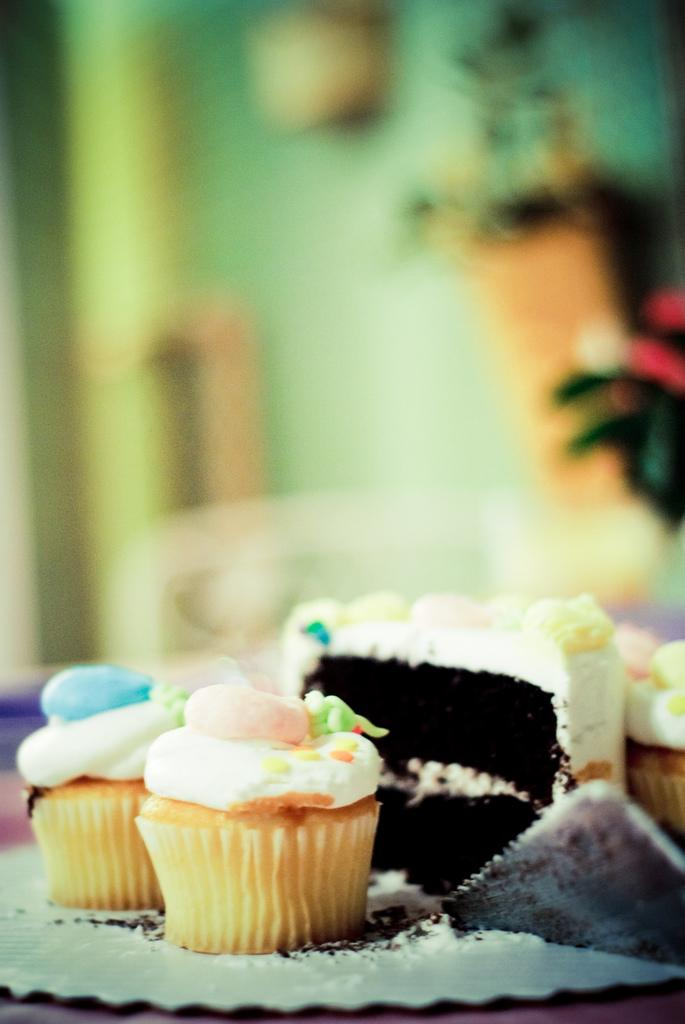What type of food items can be seen in the image? There are muffins and pastries in the image. How are the muffins and pastries arranged in the image? The muffins and pastries are on a plate in the image. Where is the plate with the muffins and pastries located? The plate is placed on a table in the image. What can be seen in the background of the image? There is a wall visible in the image. How long does it take for the muffins to control the pastries in the image? There is no indication in the image that the muffins are controlling the pastries, and the concept of time does not apply to this situation. 